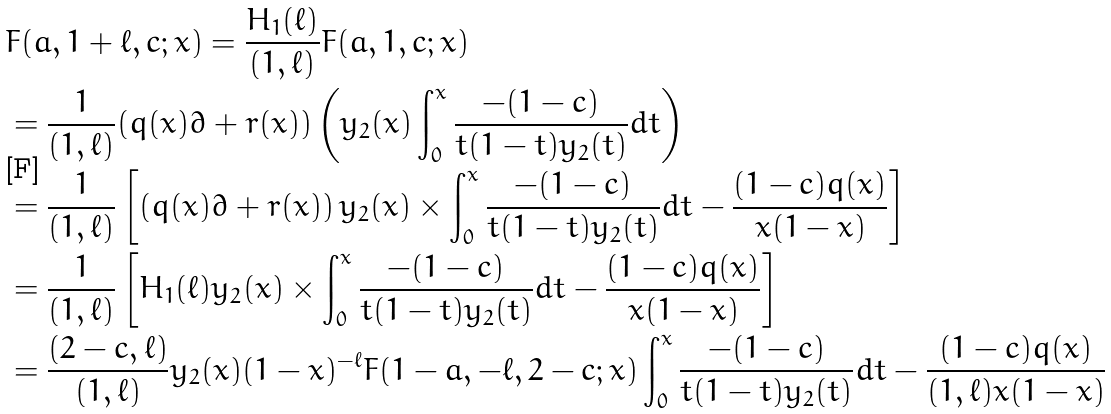Convert formula to latex. <formula><loc_0><loc_0><loc_500><loc_500>& F ( a , 1 + \ell , c ; x ) = \frac { H _ { 1 } ( \ell ) } { ( 1 , \ell ) } F ( a , 1 , c ; x ) \\ & = \frac { 1 } { ( 1 , \ell ) } ( q ( x ) \partial + r ( x ) ) \left ( y _ { 2 } ( x ) \int _ { 0 } ^ { x } \frac { - ( 1 - c ) } { t ( 1 - t ) y _ { 2 } ( t ) } d t \right ) \\ & = \frac { 1 } { ( 1 , \ell ) } \left [ \left ( q ( x ) \partial + r ( x ) \right ) y _ { 2 } ( x ) \times \int _ { 0 } ^ { x } \frac { - ( 1 - c ) } { t ( 1 - t ) y _ { 2 } ( t ) } d t - \frac { ( 1 - c ) q ( x ) } { x ( 1 - x ) } \right ] \\ & = \frac { 1 } { ( 1 , \ell ) } \left [ H _ { 1 } ( \ell ) y _ { 2 } ( x ) \times \int _ { 0 } ^ { x } \frac { - ( 1 - c ) } { t ( 1 - t ) y _ { 2 } ( t ) } d t - \frac { ( 1 - c ) q ( x ) } { x ( 1 - x ) } \right ] \\ & = \frac { ( 2 - c , \ell ) } { ( 1 , \ell ) } y _ { 2 } ( x ) ( 1 - x ) ^ { - \ell } F ( 1 - a , - \ell , 2 - c ; x ) \int _ { 0 } ^ { x } \frac { - ( 1 - c ) } { t ( 1 - t ) y _ { 2 } ( t ) } d t - \frac { ( 1 - c ) q ( x ) } { ( 1 , \ell ) x ( 1 - x ) }</formula> 